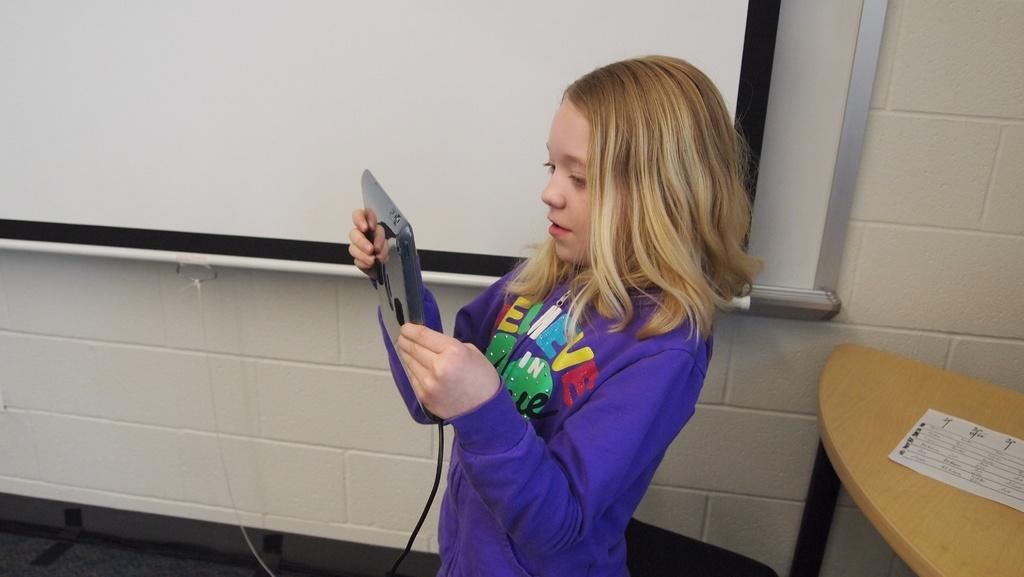Who is the main subject in the image? There is a girl in the image. What is the girl doing in the image? The girl is standing in the image. What object is the girl holding in her hand? The girl is holding an iPad in her hand. What type of base is the girl using to support her iPad in the image? There is no base visible in the image; the girl is holding the iPad in her hand. 